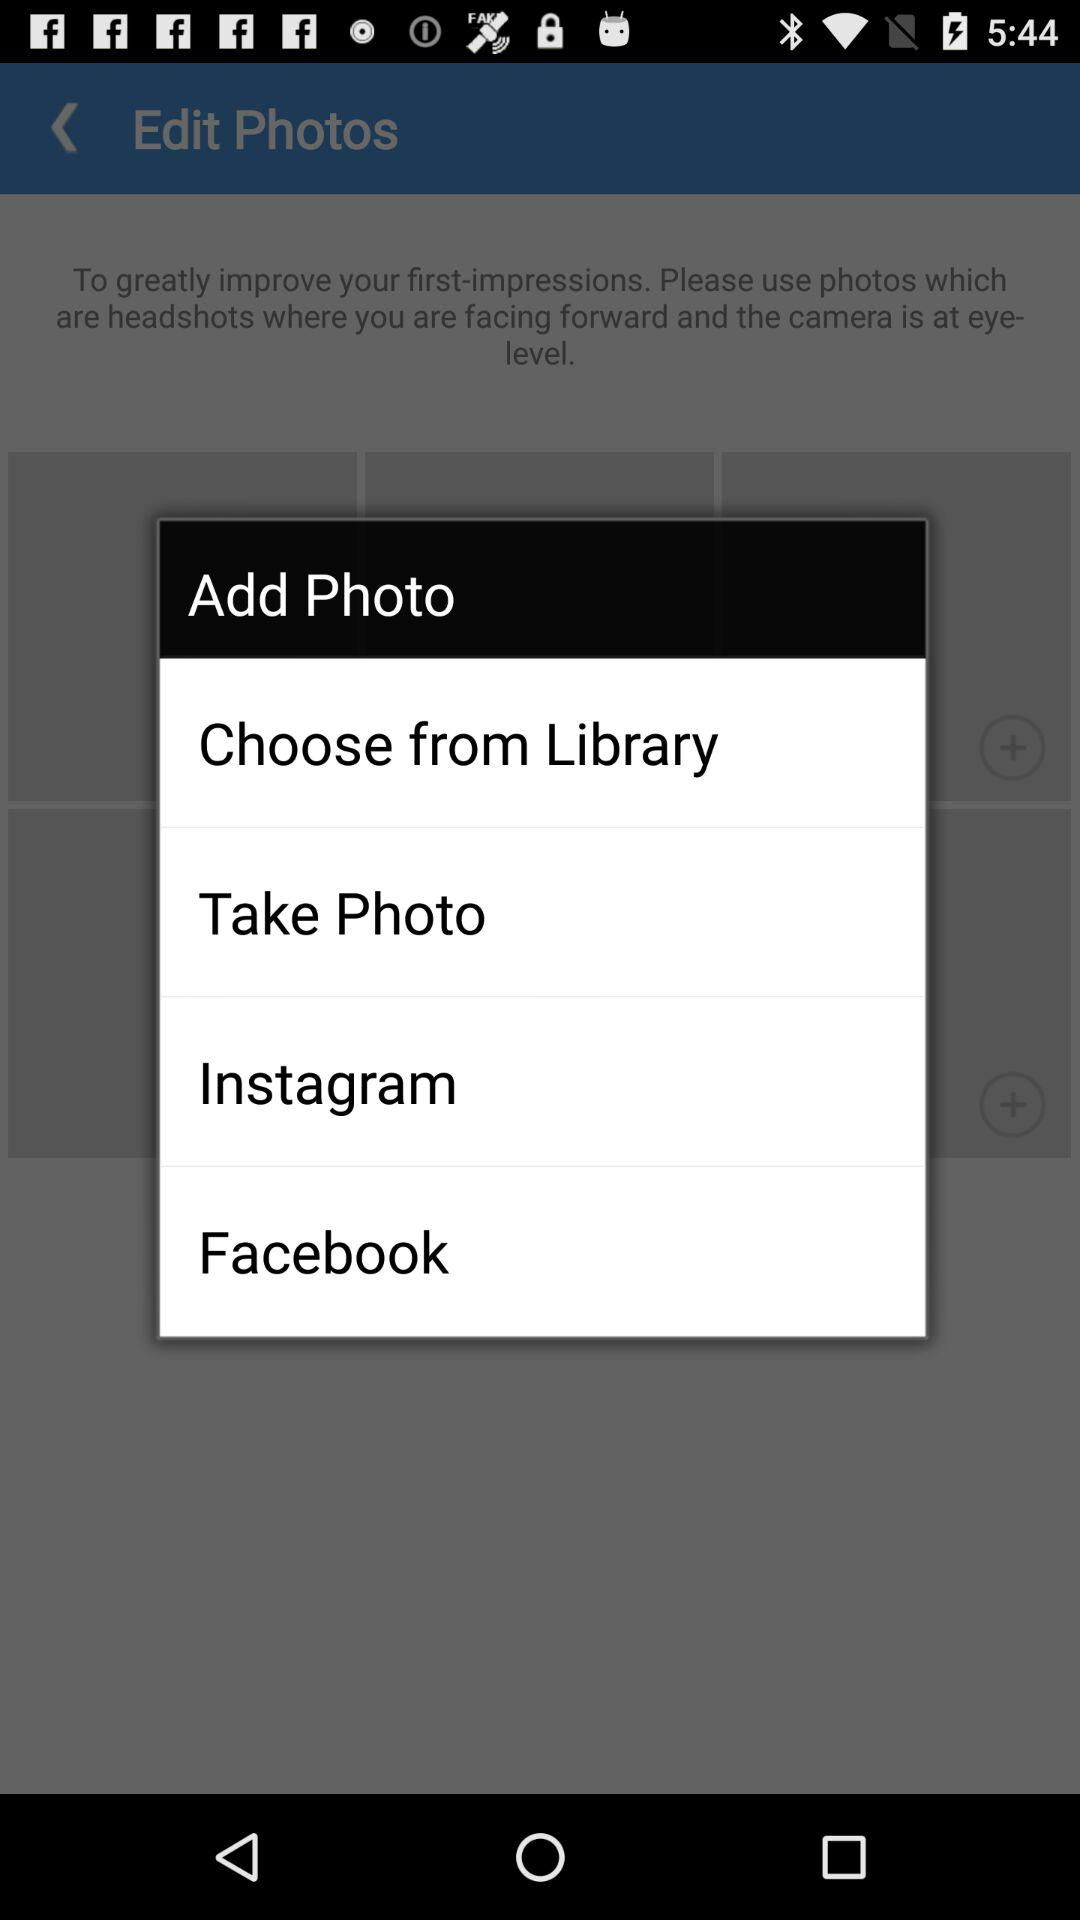Which options are given to add a photo? The options are "Choose from Library", "Take Photo", "Instagram" and "Facebook". 